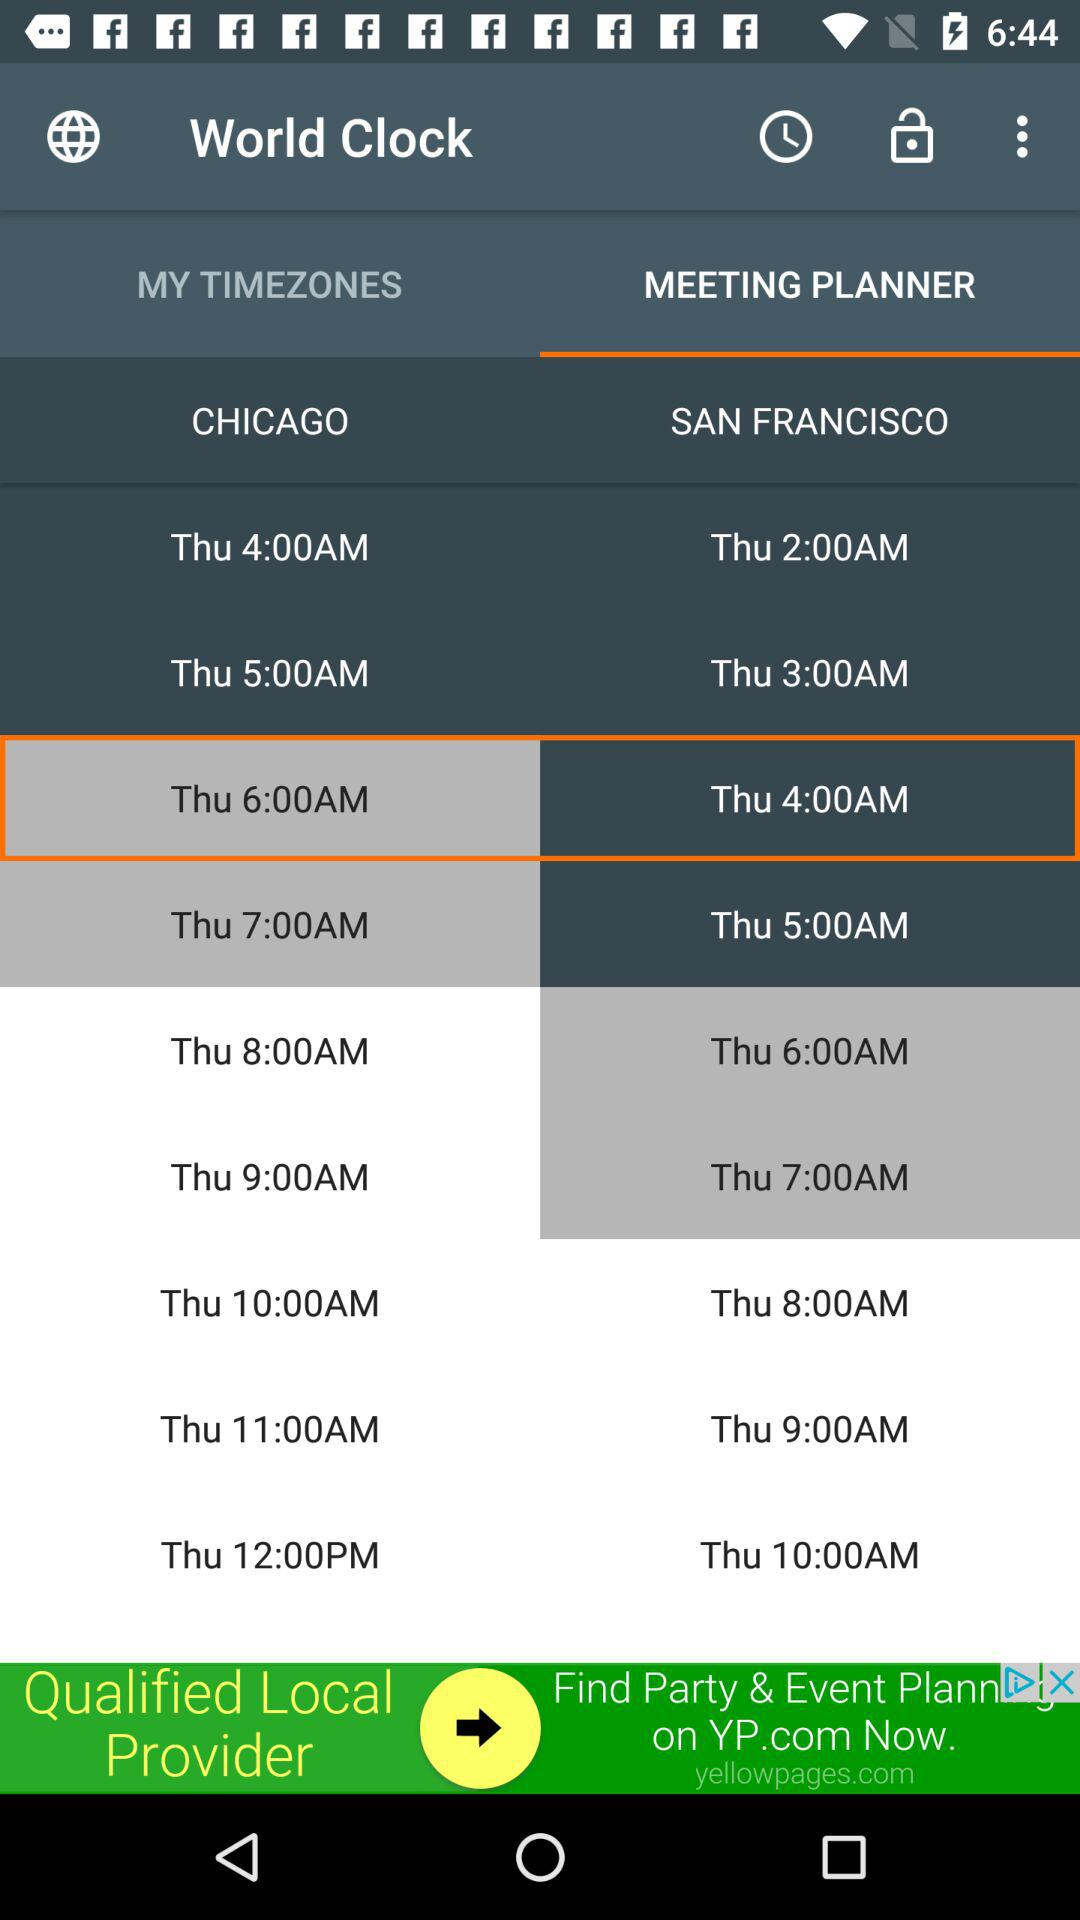Which tab is selected for the world clock? The selected tab is "MEETING PLANNER". 